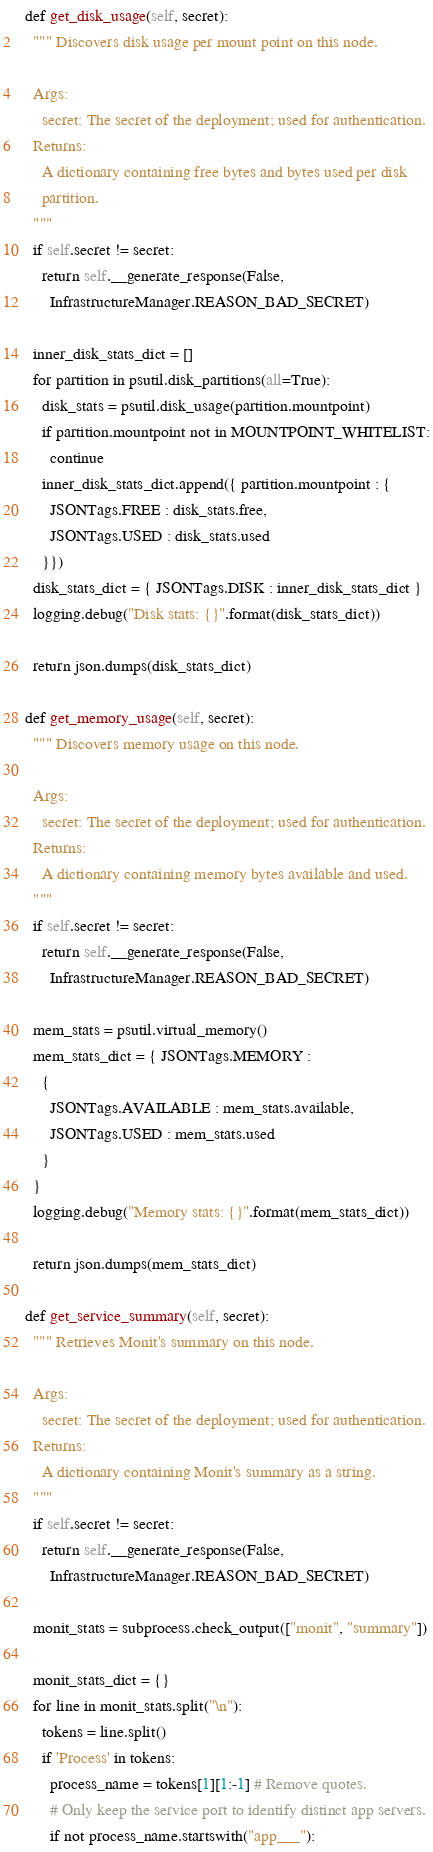Convert code to text. <code><loc_0><loc_0><loc_500><loc_500><_Python_>
  def get_disk_usage(self, secret):
    """ Discovers disk usage per mount point on this node.

    Args:
      secret: The secret of the deployment; used for authentication.
    Returns:
      A dictionary containing free bytes and bytes used per disk
      partition.
    """
    if self.secret != secret:
      return self.__generate_response(False,
        InfrastructureManager.REASON_BAD_SECRET)

    inner_disk_stats_dict = []
    for partition in psutil.disk_partitions(all=True):
      disk_stats = psutil.disk_usage(partition.mountpoint)
      if partition.mountpoint not in MOUNTPOINT_WHITELIST:
        continue
      inner_disk_stats_dict.append({ partition.mountpoint : {
        JSONTags.FREE : disk_stats.free,
        JSONTags.USED : disk_stats.used
      }})
    disk_stats_dict = { JSONTags.DISK : inner_disk_stats_dict }
    logging.debug("Disk stats: {}".format(disk_stats_dict))

    return json.dumps(disk_stats_dict)

  def get_memory_usage(self, secret):
    """ Discovers memory usage on this node.

    Args:
      secret: The secret of the deployment; used for authentication.
    Returns:
      A dictionary containing memory bytes available and used.
    """
    if self.secret != secret:
      return self.__generate_response(False,
        InfrastructureManager.REASON_BAD_SECRET)

    mem_stats = psutil.virtual_memory()
    mem_stats_dict = { JSONTags.MEMORY :
      {
        JSONTags.AVAILABLE : mem_stats.available,
        JSONTags.USED : mem_stats.used
      }
    }
    logging.debug("Memory stats: {}".format(mem_stats_dict))

    return json.dumps(mem_stats_dict)

  def get_service_summary(self, secret):
    """ Retrieves Monit's summary on this node.

    Args:
      secret: The secret of the deployment; used for authentication.
    Returns:
      A dictionary containing Monit's summary as a string.
    """
    if self.secret != secret:
      return self.__generate_response(False,
        InfrastructureManager.REASON_BAD_SECRET)

    monit_stats = subprocess.check_output(["monit", "summary"])

    monit_stats_dict = {}
    for line in monit_stats.split("\n"):
      tokens = line.split()
      if 'Process' in tokens:
        process_name = tokens[1][1:-1] # Remove quotes.
        # Only keep the service port to identify distinct app servers.
        if not process_name.startswith("app___"):</code> 